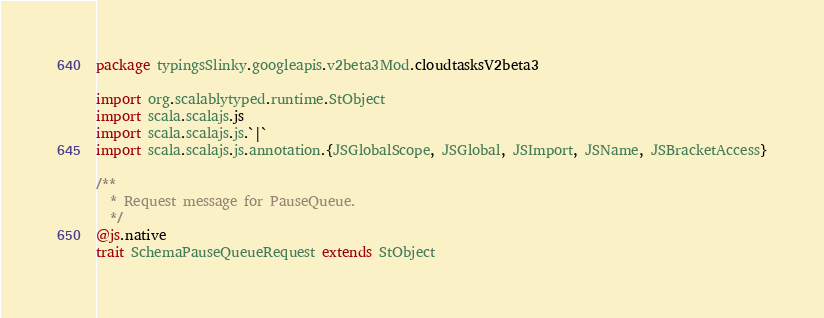Convert code to text. <code><loc_0><loc_0><loc_500><loc_500><_Scala_>package typingsSlinky.googleapis.v2beta3Mod.cloudtasksV2beta3

import org.scalablytyped.runtime.StObject
import scala.scalajs.js
import scala.scalajs.js.`|`
import scala.scalajs.js.annotation.{JSGlobalScope, JSGlobal, JSImport, JSName, JSBracketAccess}

/**
  * Request message for PauseQueue.
  */
@js.native
trait SchemaPauseQueueRequest extends StObject
</code> 